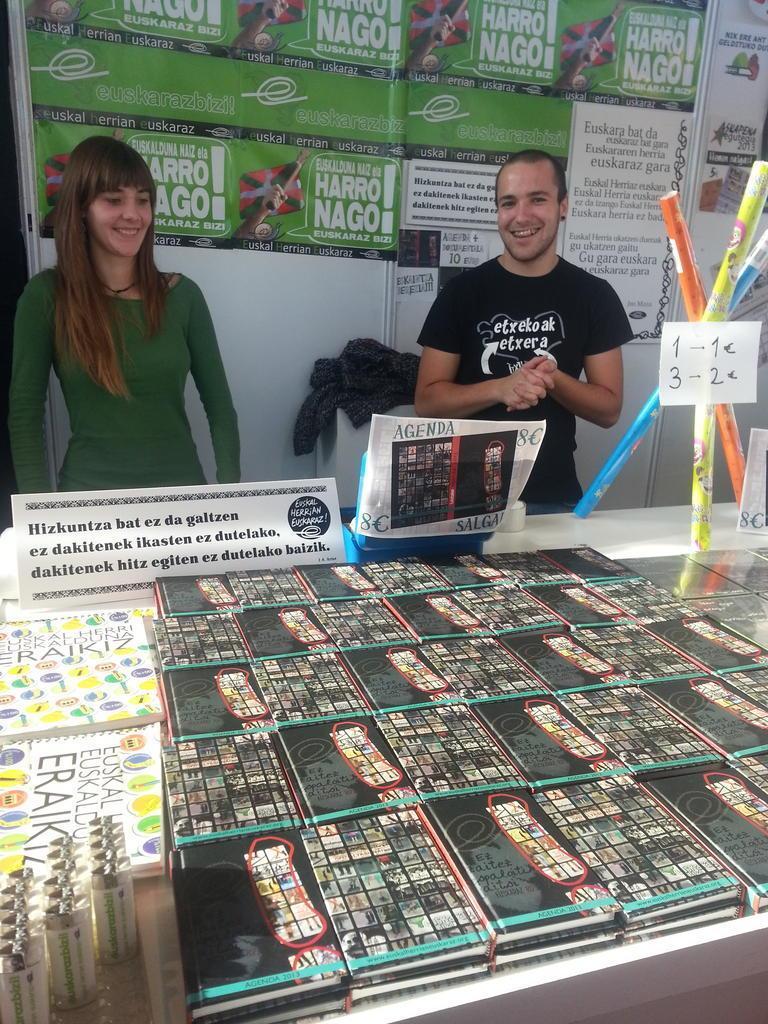How would you summarize this image in a sentence or two? In this image I can see two people are standing in front of the table on which I can see some books, boards and thing are placed, behind I can see some banners. 